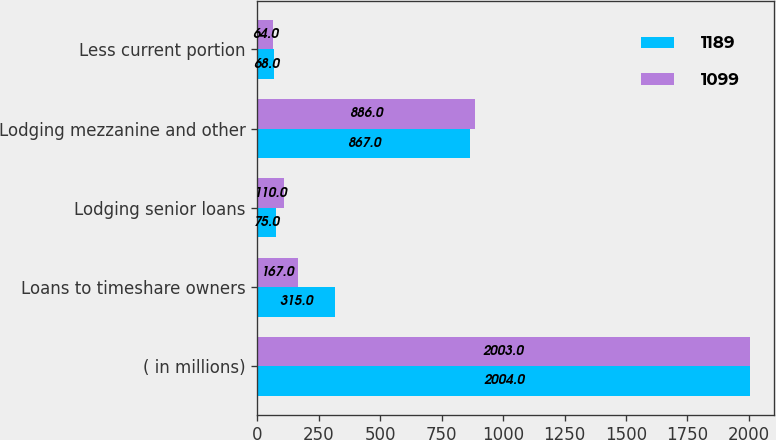Convert chart. <chart><loc_0><loc_0><loc_500><loc_500><stacked_bar_chart><ecel><fcel>( in millions)<fcel>Loans to timeshare owners<fcel>Lodging senior loans<fcel>Lodging mezzanine and other<fcel>Less current portion<nl><fcel>1189<fcel>2004<fcel>315<fcel>75<fcel>867<fcel>68<nl><fcel>1099<fcel>2003<fcel>167<fcel>110<fcel>886<fcel>64<nl></chart> 